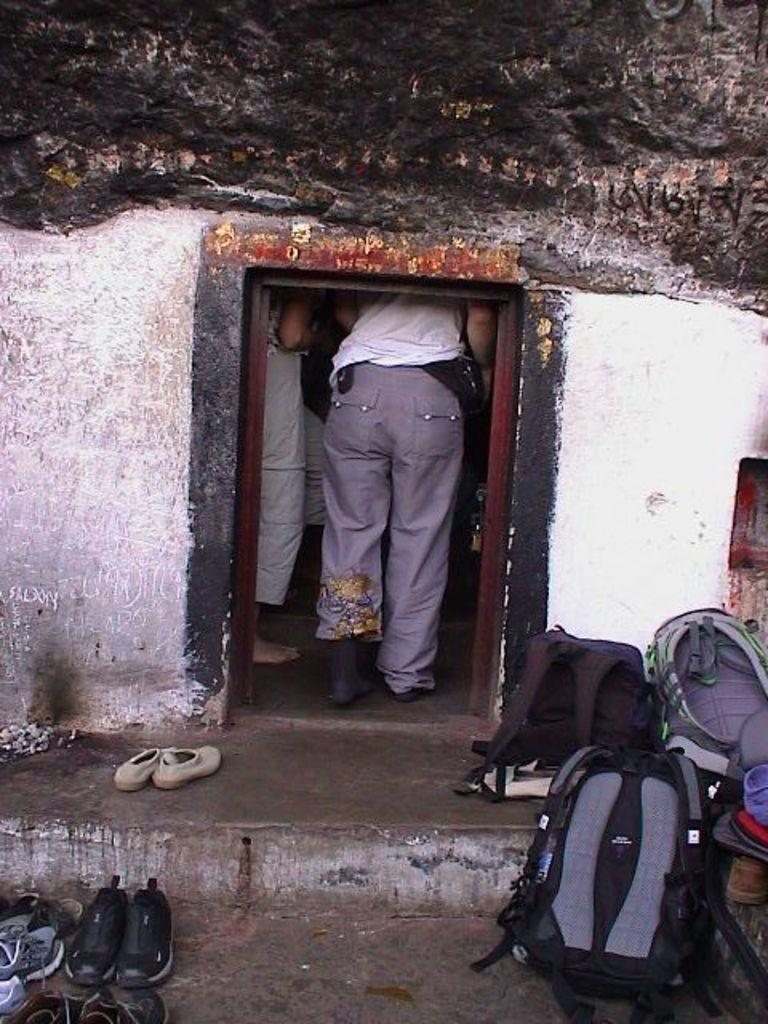What type of structure is visible in the image? There is a house in the image. Can you describe the people inside the house? Two persons are standing inside the house. What items are near the house? Backpacks and footwear are visible near the house. What type of battle is taking place in the image? There is no battle present in the image; it features a house with two persons standing inside. How many cars are parked near the house in the image? There is no mention of cars in the image; only a house, two persons, backpacks, and footwear are present. 